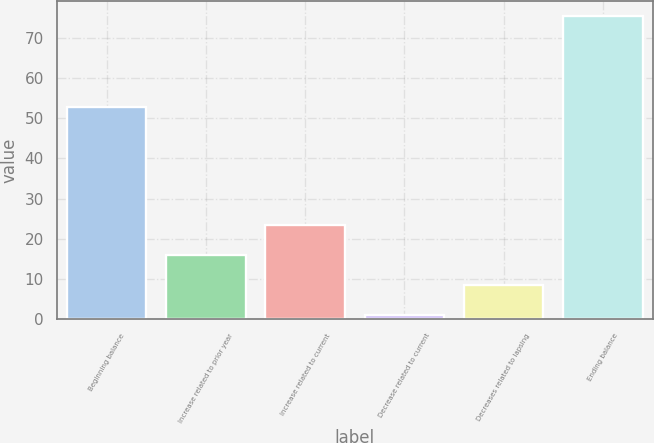Convert chart. <chart><loc_0><loc_0><loc_500><loc_500><bar_chart><fcel>Beginning balance<fcel>Increase related to prior year<fcel>Increase related to current<fcel>Decrease related to current<fcel>Decreases related to lapsing<fcel>Ending balance<nl><fcel>52.9<fcel>15.94<fcel>23.36<fcel>1.1<fcel>8.52<fcel>75.3<nl></chart> 